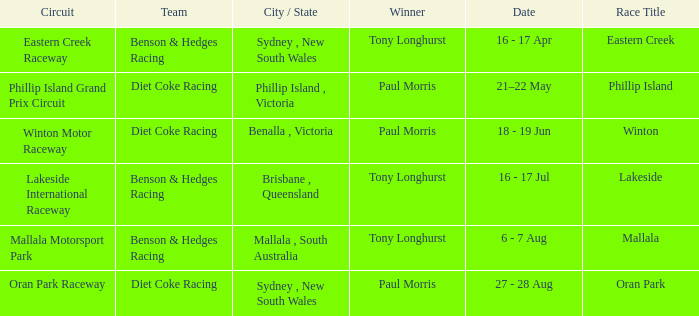What was the name of the driver that won the Lakeside race? Tony Longhurst. 